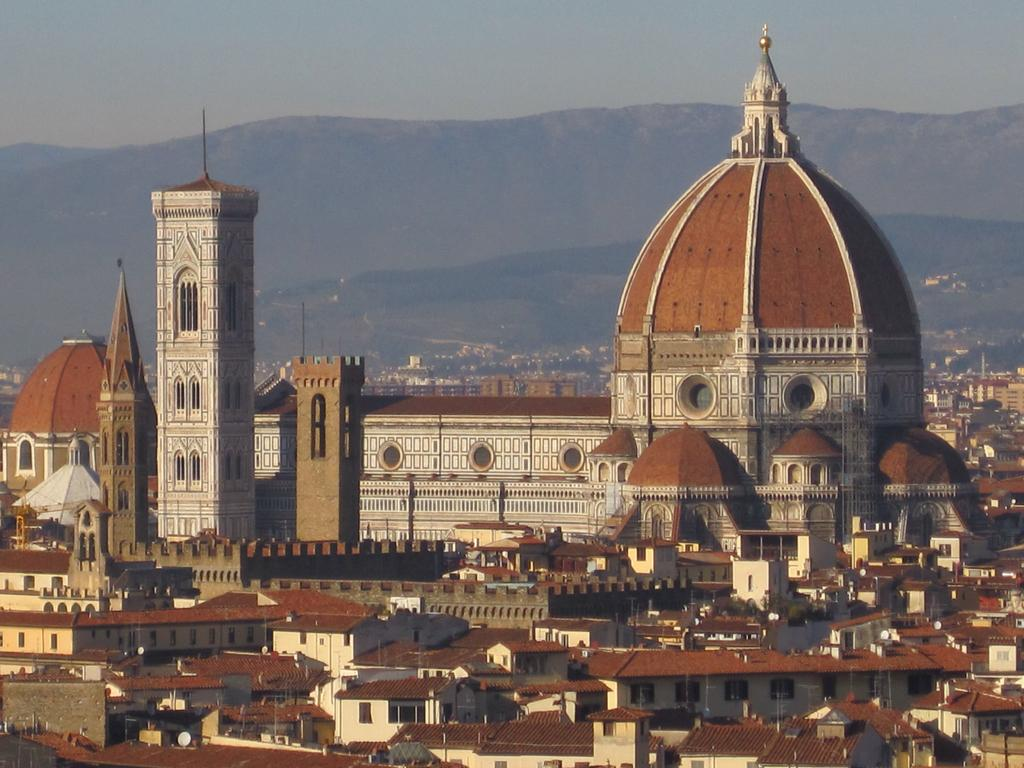What types of structures are present in the image? There are buildings and houses with roofs in the image. What can be seen in the distance behind the structures? Mountains are visible in the background of the image. What else is visible in the background of the image? The sky is visible in the background of the image. What type of power source can be seen in the image? There is no power source visible in the image; it only features buildings, houses, mountains, and the sky. 